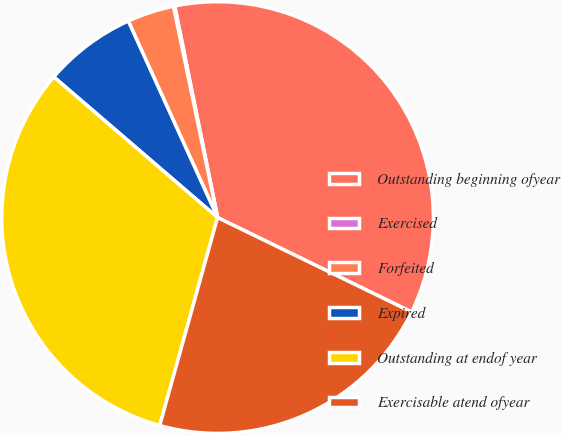Convert chart to OTSL. <chart><loc_0><loc_0><loc_500><loc_500><pie_chart><fcel>Outstanding beginning ofyear<fcel>Exercised<fcel>Forfeited<fcel>Expired<fcel>Outstanding at endof year<fcel>Exercisable atend ofyear<nl><fcel>35.39%<fcel>0.1%<fcel>3.51%<fcel>6.92%<fcel>31.98%<fcel>22.11%<nl></chart> 